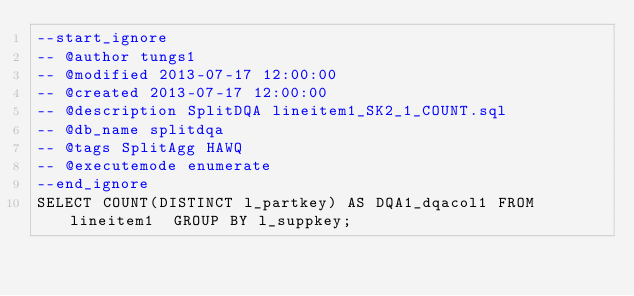Convert code to text. <code><loc_0><loc_0><loc_500><loc_500><_SQL_>--start_ignore
-- @author tungs1
-- @modified 2013-07-17 12:00:00
-- @created 2013-07-17 12:00:00
-- @description SplitDQA lineitem1_SK2_1_COUNT.sql
-- @db_name splitdqa
-- @tags SplitAgg HAWQ
-- @executemode enumerate
--end_ignore
SELECT COUNT(DISTINCT l_partkey) AS DQA1_dqacol1 FROM lineitem1  GROUP BY l_suppkey;
</code> 